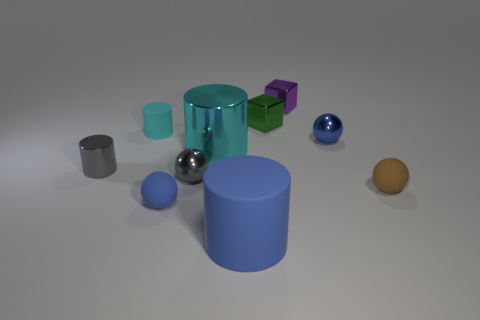What number of things are spheres right of the small blue matte ball or cubes left of the purple object?
Your response must be concise. 4. There is a shiny block behind the green metallic block; is its size the same as the tiny brown matte sphere?
Provide a short and direct response. Yes. What size is the blue matte object that is the same shape as the brown object?
Your answer should be compact. Small. What is the material of the other cylinder that is the same size as the blue cylinder?
Offer a terse response. Metal. There is a gray object that is the same shape as the small brown thing; what is it made of?
Your answer should be compact. Metal. How many other objects are there of the same size as the cyan matte object?
Provide a short and direct response. 7. What is the size of the other cylinder that is the same color as the large shiny cylinder?
Your answer should be very brief. Small. How many small spheres are the same color as the small rubber cylinder?
Provide a short and direct response. 0. What is the shape of the purple metallic object?
Give a very brief answer. Cube. What color is the sphere that is behind the brown rubber ball and on the right side of the big blue rubber thing?
Your answer should be compact. Blue. 